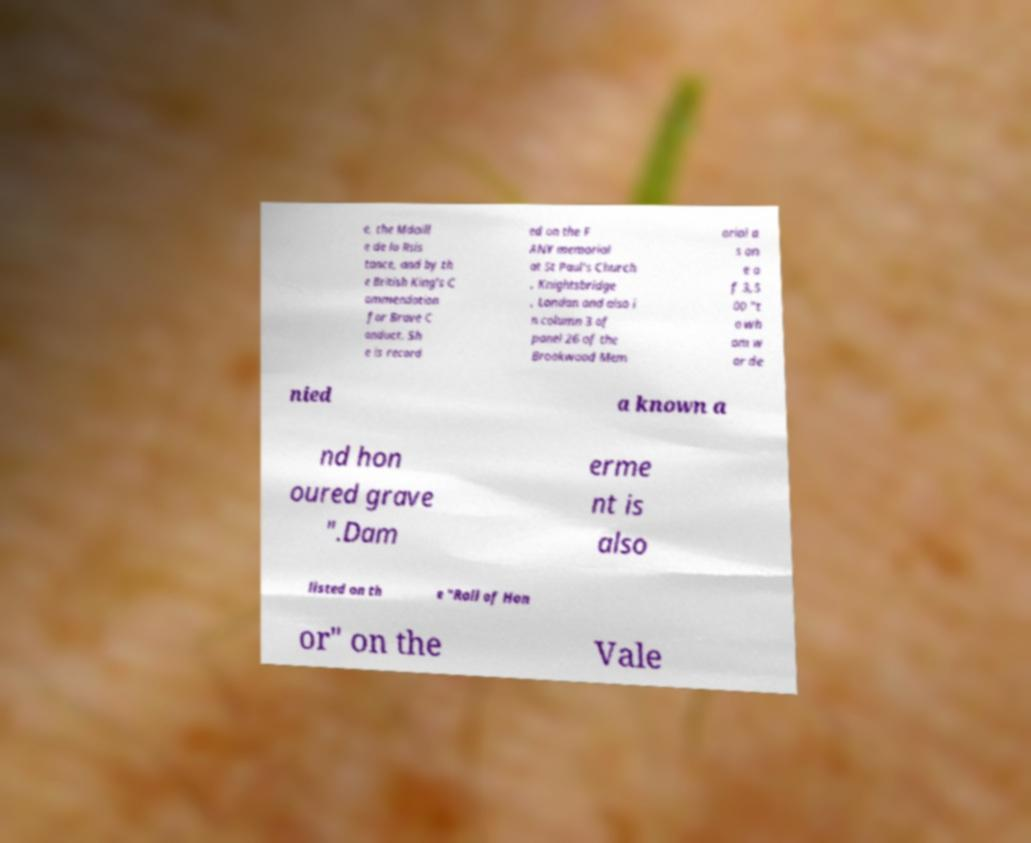Please read and relay the text visible in this image. What does it say? e, the Mdaill e de la Rsis tance, and by th e British King's C ommendation for Brave C onduct. Sh e is record ed on the F ANY memorial at St Paul's Church , Knightsbridge , London and also i n column 3 of panel 26 of the Brookwood Mem orial a s on e o f 3,5 00 "t o wh om w ar de nied a known a nd hon oured grave ".Dam erme nt is also listed on th e "Roll of Hon or" on the Vale 